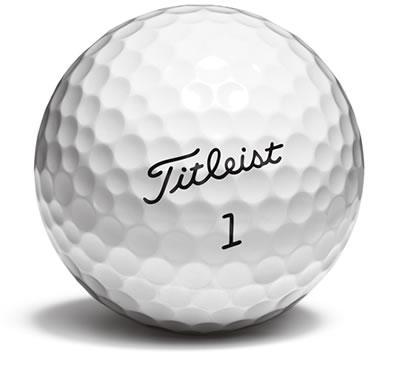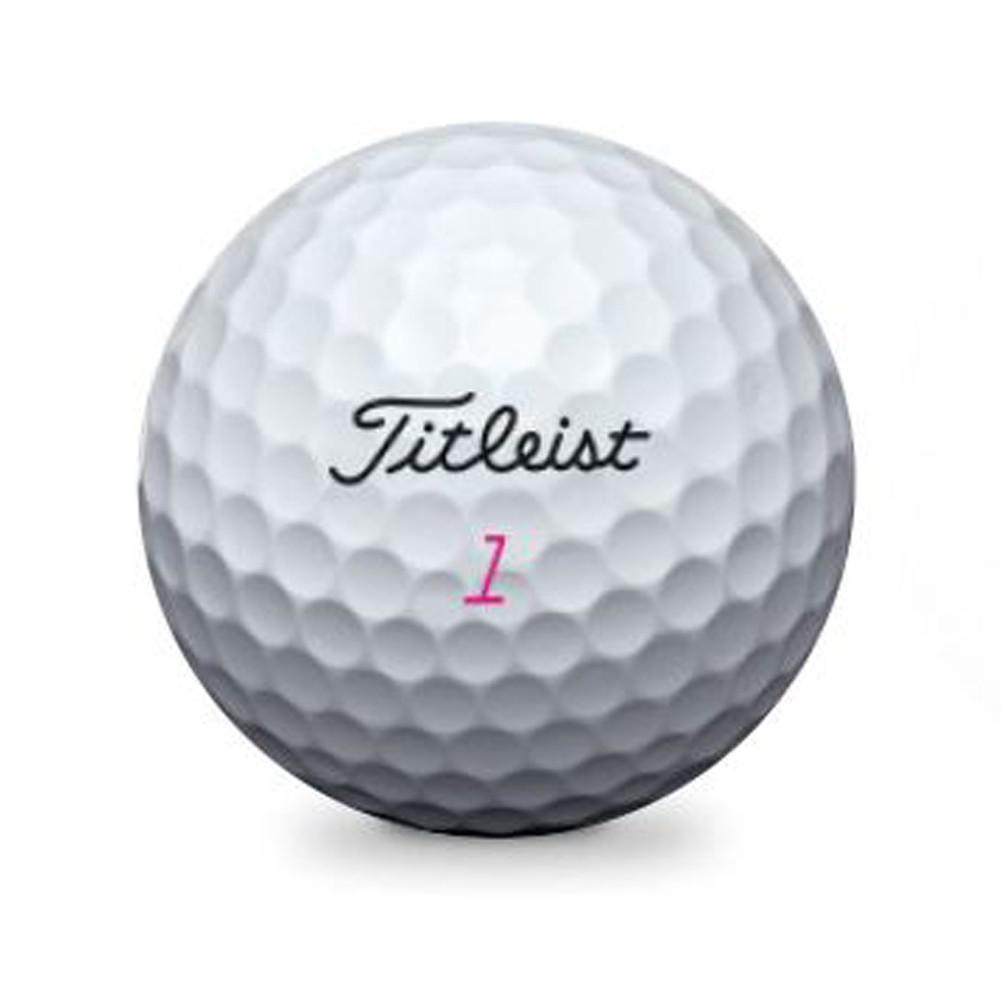The first image is the image on the left, the second image is the image on the right. Assess this claim about the two images: "A golf ball is near a black golf club". Correct or not? Answer yes or no. No. 